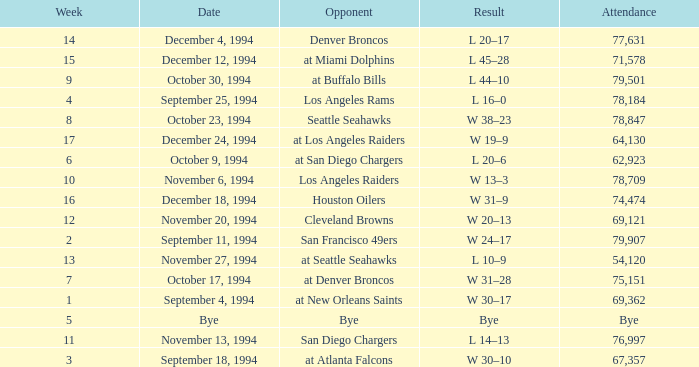What was the score of the Chiefs pre-Week 16 game that 69,362 people attended? W 30–17. 